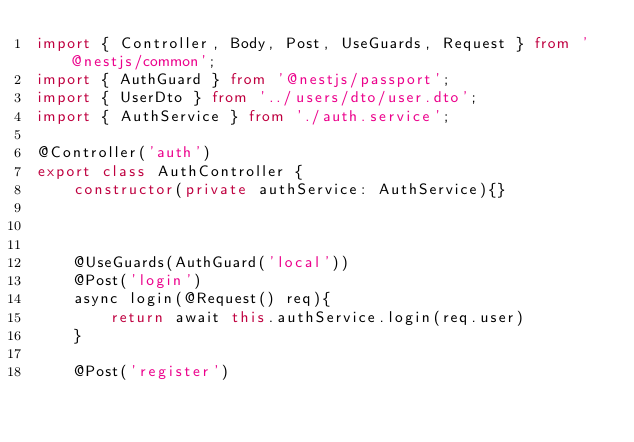<code> <loc_0><loc_0><loc_500><loc_500><_TypeScript_>import { Controller, Body, Post, UseGuards, Request } from '@nestjs/common';
import { AuthGuard } from '@nestjs/passport';
import { UserDto } from '../users/dto/user.dto';
import { AuthService } from './auth.service';

@Controller('auth')
export class AuthController {
    constructor(private authService: AuthService){}



    @UseGuards(AuthGuard('local'))
    @Post('login')
    async login(@Request() req){
        return await this.authService.login(req.user)
    }

    @Post('register')</code> 